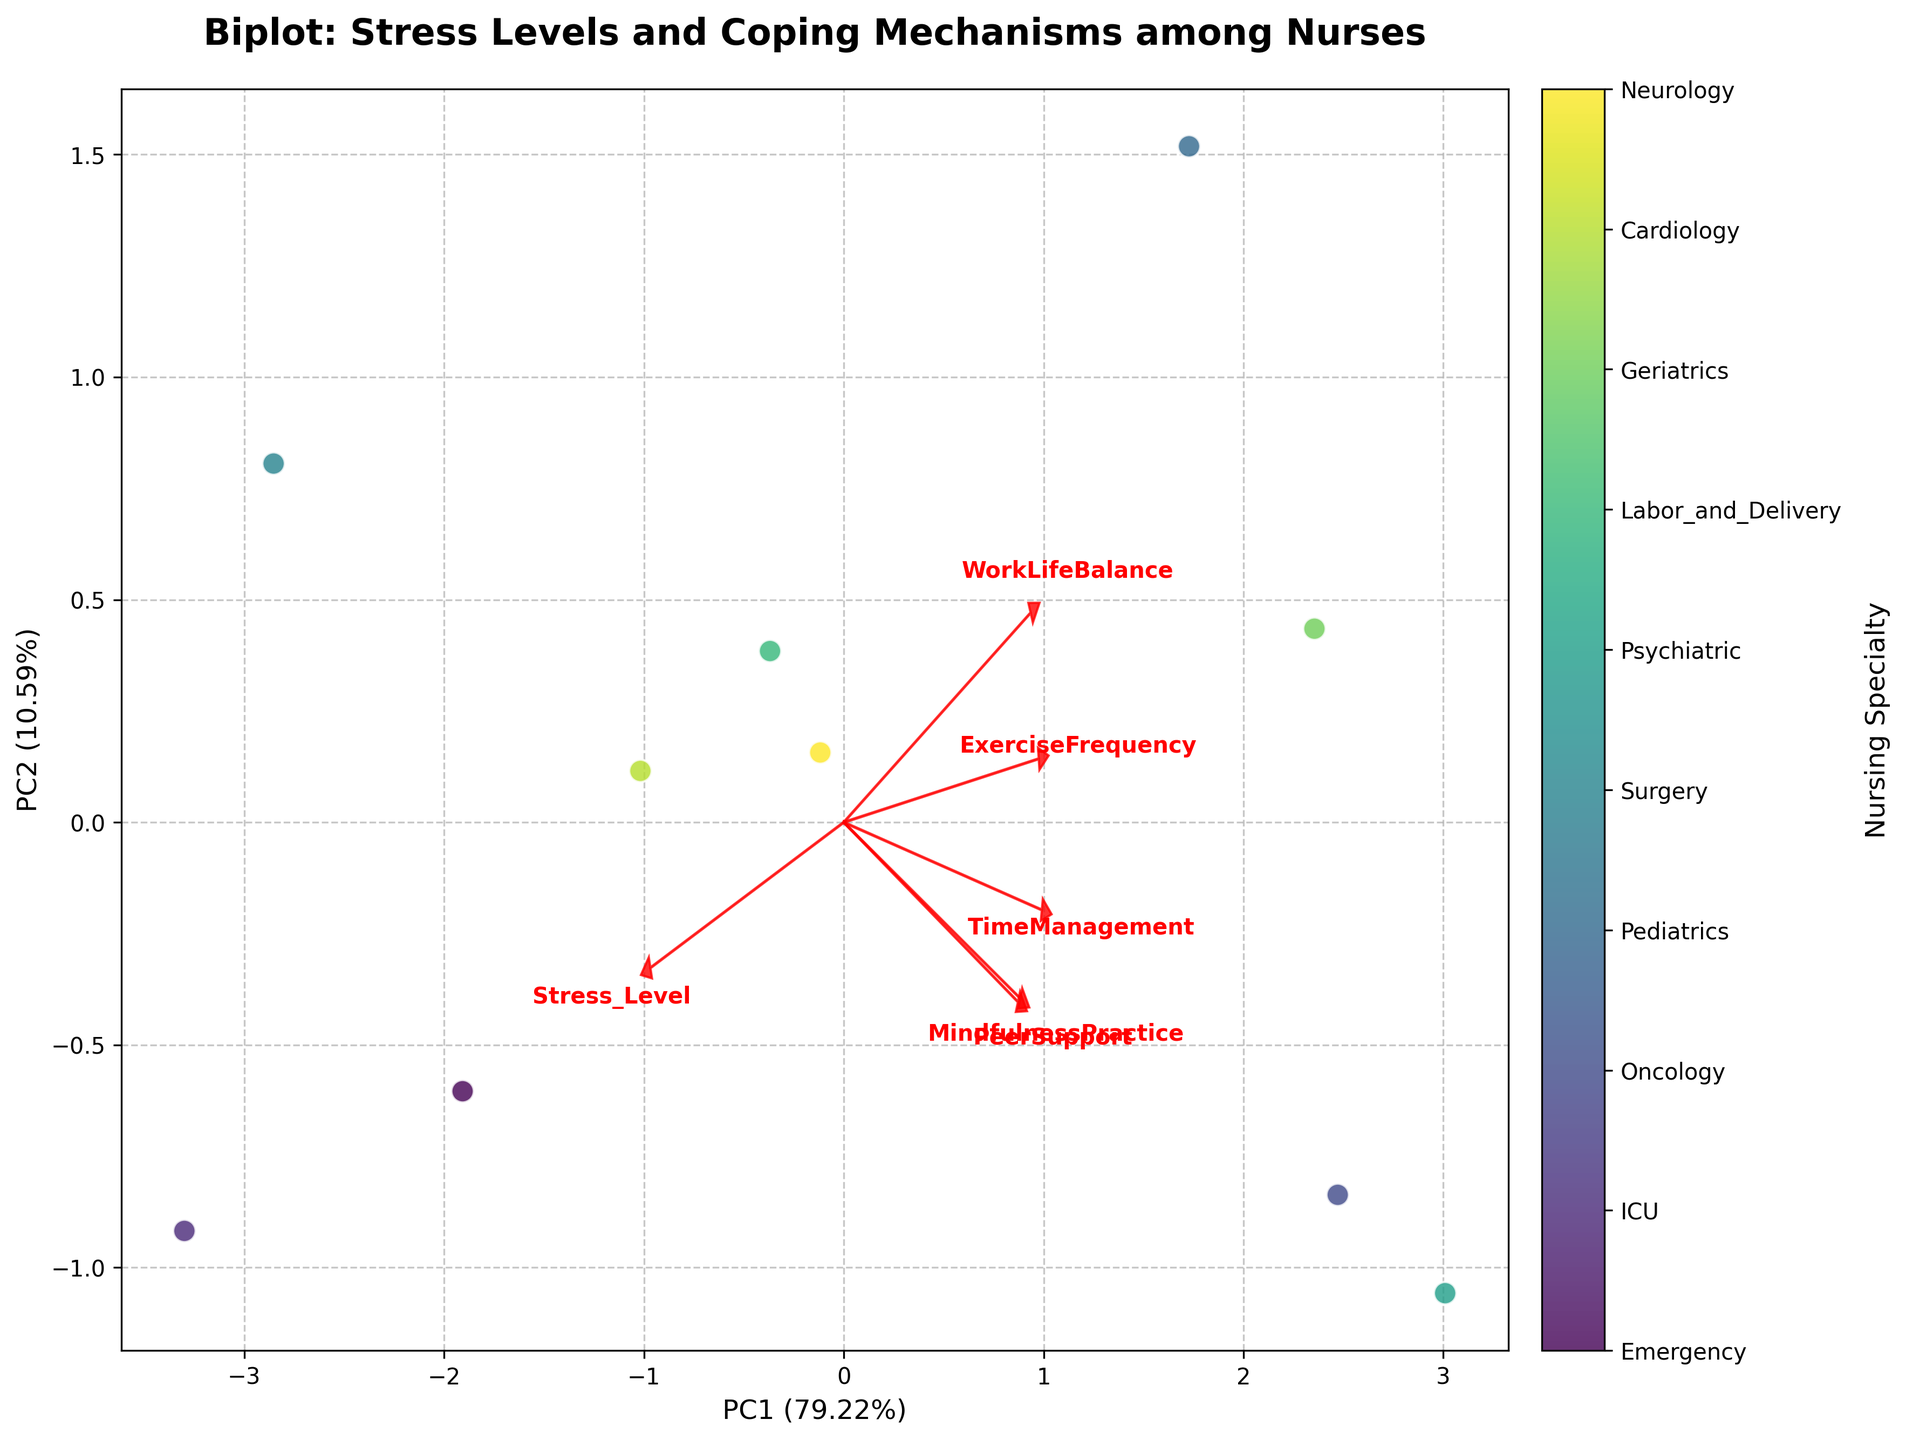How many nursing specialties are compared in the figure? Count the number of distinct points in the scatter plot. Each point represents a nursing specialty.
Answer: 10 Which principal component explains more variance in the data? Look at the labels for the x and y axes. The percentage of explained variance is indicated in parentheses. Compare the two values.
Answer: PC1 Which specialty has the highest stress level according to the plot? Find the point in the scatter plot labeled with each specialty and check the relationship of the loadings arrow for 'Stress_Level.' The specialty closest to the end of this arrow has the highest stress level.
Answer: ICU Do 'ExerciseFrequency' and 'Stress_Level' have similar loading directions on the plot? Look at the direction of the arrows for 'ExerciseFrequency' and 'Stress_Level.' Check if they point in similar or different directions.
Answer: Different directions Which two specialties are the most distinct from each other in terms of coping mechanisms? Look for the points in the scatter plot that are farthest apart. The larger the distance, the more distinct they are in terms of their coping mechanisms as determined by PC1 and PC2.
Answer: ICU and Psychiatric What does the arrow labeled 'PeerSupport' indicate about the relationship with the two principal components? Observe the direction and length of the 'PeerSupport' arrow. An arrow pointing in a particular direction generally indicates a positive correlation with that component.
Answer: High positive correlation with PC2 Explain how 'MindfulnessPractice' seems to relate to stress levels among the specialties. Look at the direction and length of the arrow labeled 'MindfulnessPractice' in relation to the 'Stress_Level' arrow. If they point in opposite directions, an inverse relationship is implied.
Answer: Inverse relationship Which specialty has the best work-life balance according to the plot? Find the loadings arrow for 'WorkLifeBalance' and identify which specialty's point is nearest to the end of this arrow.
Answer: Pediatrics Are 'TimeManagement' and 'PeerSupport' positively correlated according to their loading vectors? Compare the directions of the arrows for 'TimeManagement' and 'PeerSupport.' If both arrows point in similar directions, they are positively correlated.
Answer: Positively correlated Which principal component (PC) is closely associated with 'MindfulnessPractice'? Identify the arrow for 'MindfulnessPractice' and note which axis it aligns closely with. The side of the arrow that it leans towards indicates the associated PC.
Answer: PC2 